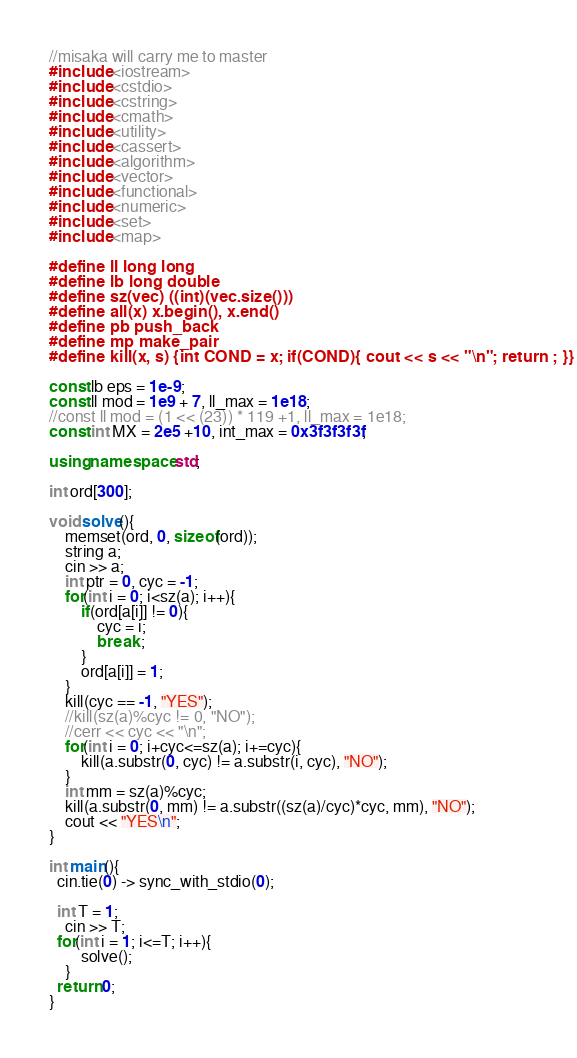<code> <loc_0><loc_0><loc_500><loc_500><_C++_>
//misaka will carry me to master
#include <iostream>
#include <cstdio>
#include <cstring>
#include <cmath>
#include <utility>
#include <cassert>
#include <algorithm>
#include <vector>
#include <functional>
#include <numeric>
#include <set>
#include <map>

#define ll long long
#define lb long double
#define sz(vec) ((int)(vec.size()))
#define all(x) x.begin(), x.end()
#define pb push_back
#define mp make_pair
#define kill(x, s) {int COND = x; if(COND){ cout << s << "\n"; return ; }}

const lb eps = 1e-9;
const ll mod = 1e9 + 7, ll_max = 1e18;
//const ll mod = (1 << (23)) * 119 +1, ll_max = 1e18;
const int MX = 2e5 +10, int_max = 0x3f3f3f3f;

using namespace std;

int ord[300];

void solve(){
	memset(ord, 0, sizeof(ord));
	string a;
	cin >> a;
	int ptr = 0, cyc = -1;
	for(int i = 0; i<sz(a); i++){
		if(ord[a[i]] != 0){
			cyc = i;
			break ;
		}
		ord[a[i]] = 1;
	}	
	kill(cyc == -1, "YES");
	//kill(sz(a)%cyc != 0, "NO");
	//cerr << cyc << "\n";
	for(int i = 0; i+cyc<=sz(a); i+=cyc){
		kill(a.substr(0, cyc) != a.substr(i, cyc), "NO");	
	}
	int mm = sz(a)%cyc;
	kill(a.substr(0, mm) != a.substr((sz(a)/cyc)*cyc, mm), "NO");
	cout << "YES\n";
}

int main(){
  cin.tie(0) -> sync_with_stdio(0);

  int T = 1;
	cin >> T;
  for(int i = 1; i<=T; i++){
		solve();
	}
  return 0;
}



</code> 